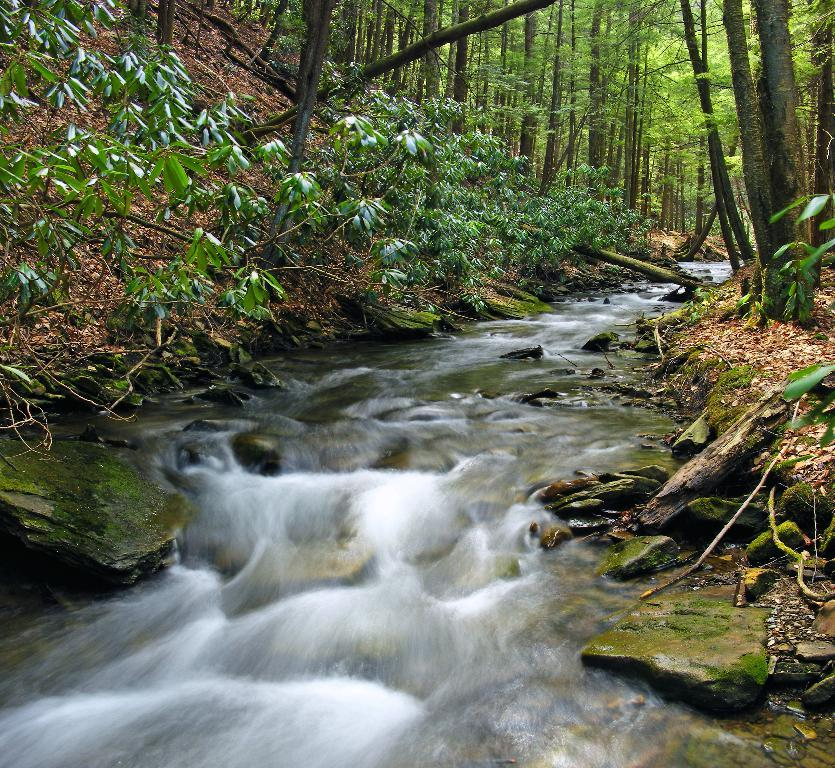What is the primary element visible in the image? There is water in the image. What can be seen on the ground in the image? The ground is visible in the image, with some dried leaves. What type of vegetation is present in the image? There are plants and trees in the image. What other natural features can be seen in the image? There are rocks in the image. Can you tell me how many fire hydrants are visible in the image? There are no fire hydrants present in the image. What type of water is being offered by the plants in the image? The image does not depict plants offering water; there are simply plants and trees present. 